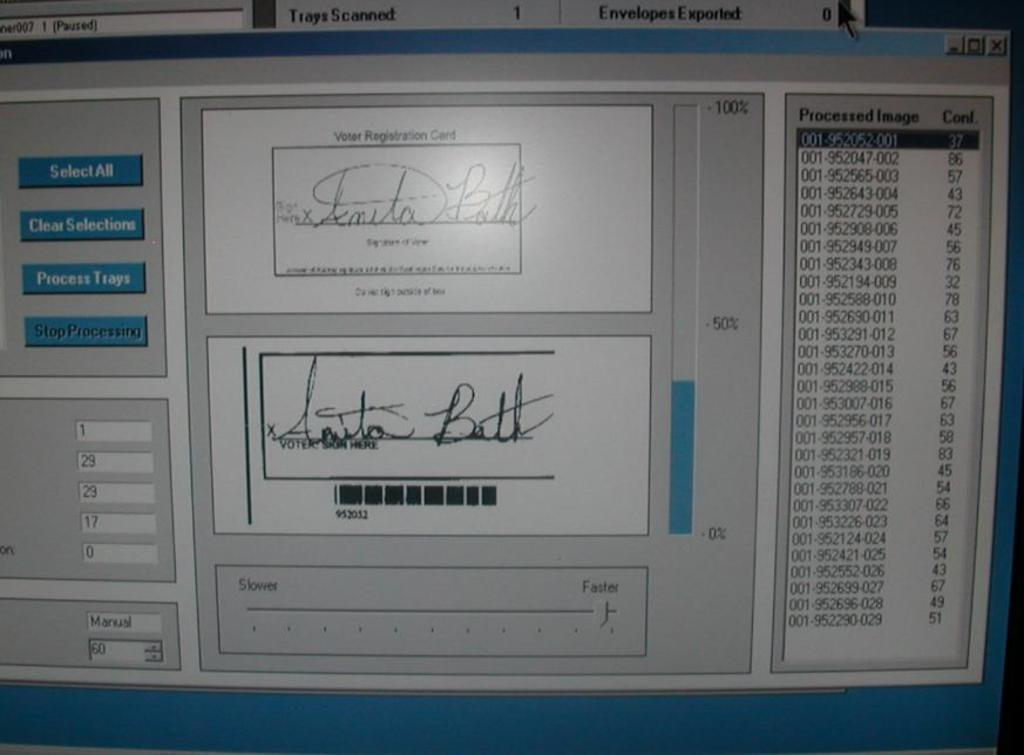Provide a one-sentence caption for the provided image. A vote counting program showing a digital scan of a signature as it scans voter registration cards.. 